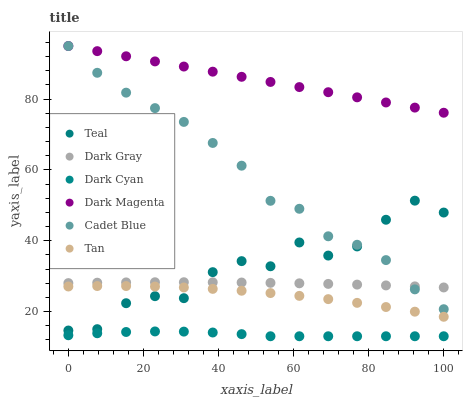Does Dark Cyan have the minimum area under the curve?
Answer yes or no. Yes. Does Dark Magenta have the maximum area under the curve?
Answer yes or no. Yes. Does Dark Gray have the minimum area under the curve?
Answer yes or no. No. Does Dark Gray have the maximum area under the curve?
Answer yes or no. No. Is Dark Magenta the smoothest?
Answer yes or no. Yes. Is Teal the roughest?
Answer yes or no. Yes. Is Dark Gray the smoothest?
Answer yes or no. No. Is Dark Gray the roughest?
Answer yes or no. No. Does Dark Cyan have the lowest value?
Answer yes or no. Yes. Does Dark Gray have the lowest value?
Answer yes or no. No. Does Dark Magenta have the highest value?
Answer yes or no. Yes. Does Dark Gray have the highest value?
Answer yes or no. No. Is Tan less than Dark Gray?
Answer yes or no. Yes. Is Cadet Blue greater than Dark Cyan?
Answer yes or no. Yes. Does Cadet Blue intersect Dark Gray?
Answer yes or no. Yes. Is Cadet Blue less than Dark Gray?
Answer yes or no. No. Is Cadet Blue greater than Dark Gray?
Answer yes or no. No. Does Tan intersect Dark Gray?
Answer yes or no. No. 